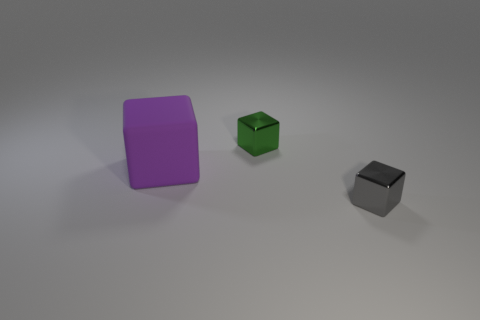Is there any other thing that is the same size as the purple thing?
Make the answer very short. No. How many matte objects are behind the tiny metal block behind the small gray cube?
Ensure brevity in your answer.  0. How many other purple objects have the same material as the large thing?
Make the answer very short. 0. There is a purple matte thing; are there any small cubes behind it?
Offer a terse response. Yes. There is a object that is the same size as the green shiny block; what color is it?
Offer a very short reply. Gray. How many objects are either shiny cubes to the left of the gray thing or large yellow cylinders?
Provide a short and direct response. 1. There is a cube that is both right of the big rubber thing and on the left side of the small gray metal thing; what is its size?
Make the answer very short. Small. What number of other objects are the same size as the gray shiny block?
Your response must be concise. 1. The small shiny object behind the tiny object that is in front of the metallic block on the left side of the gray block is what color?
Make the answer very short. Green. What shape is the object that is in front of the green shiny thing and behind the gray metallic block?
Provide a short and direct response. Cube. 